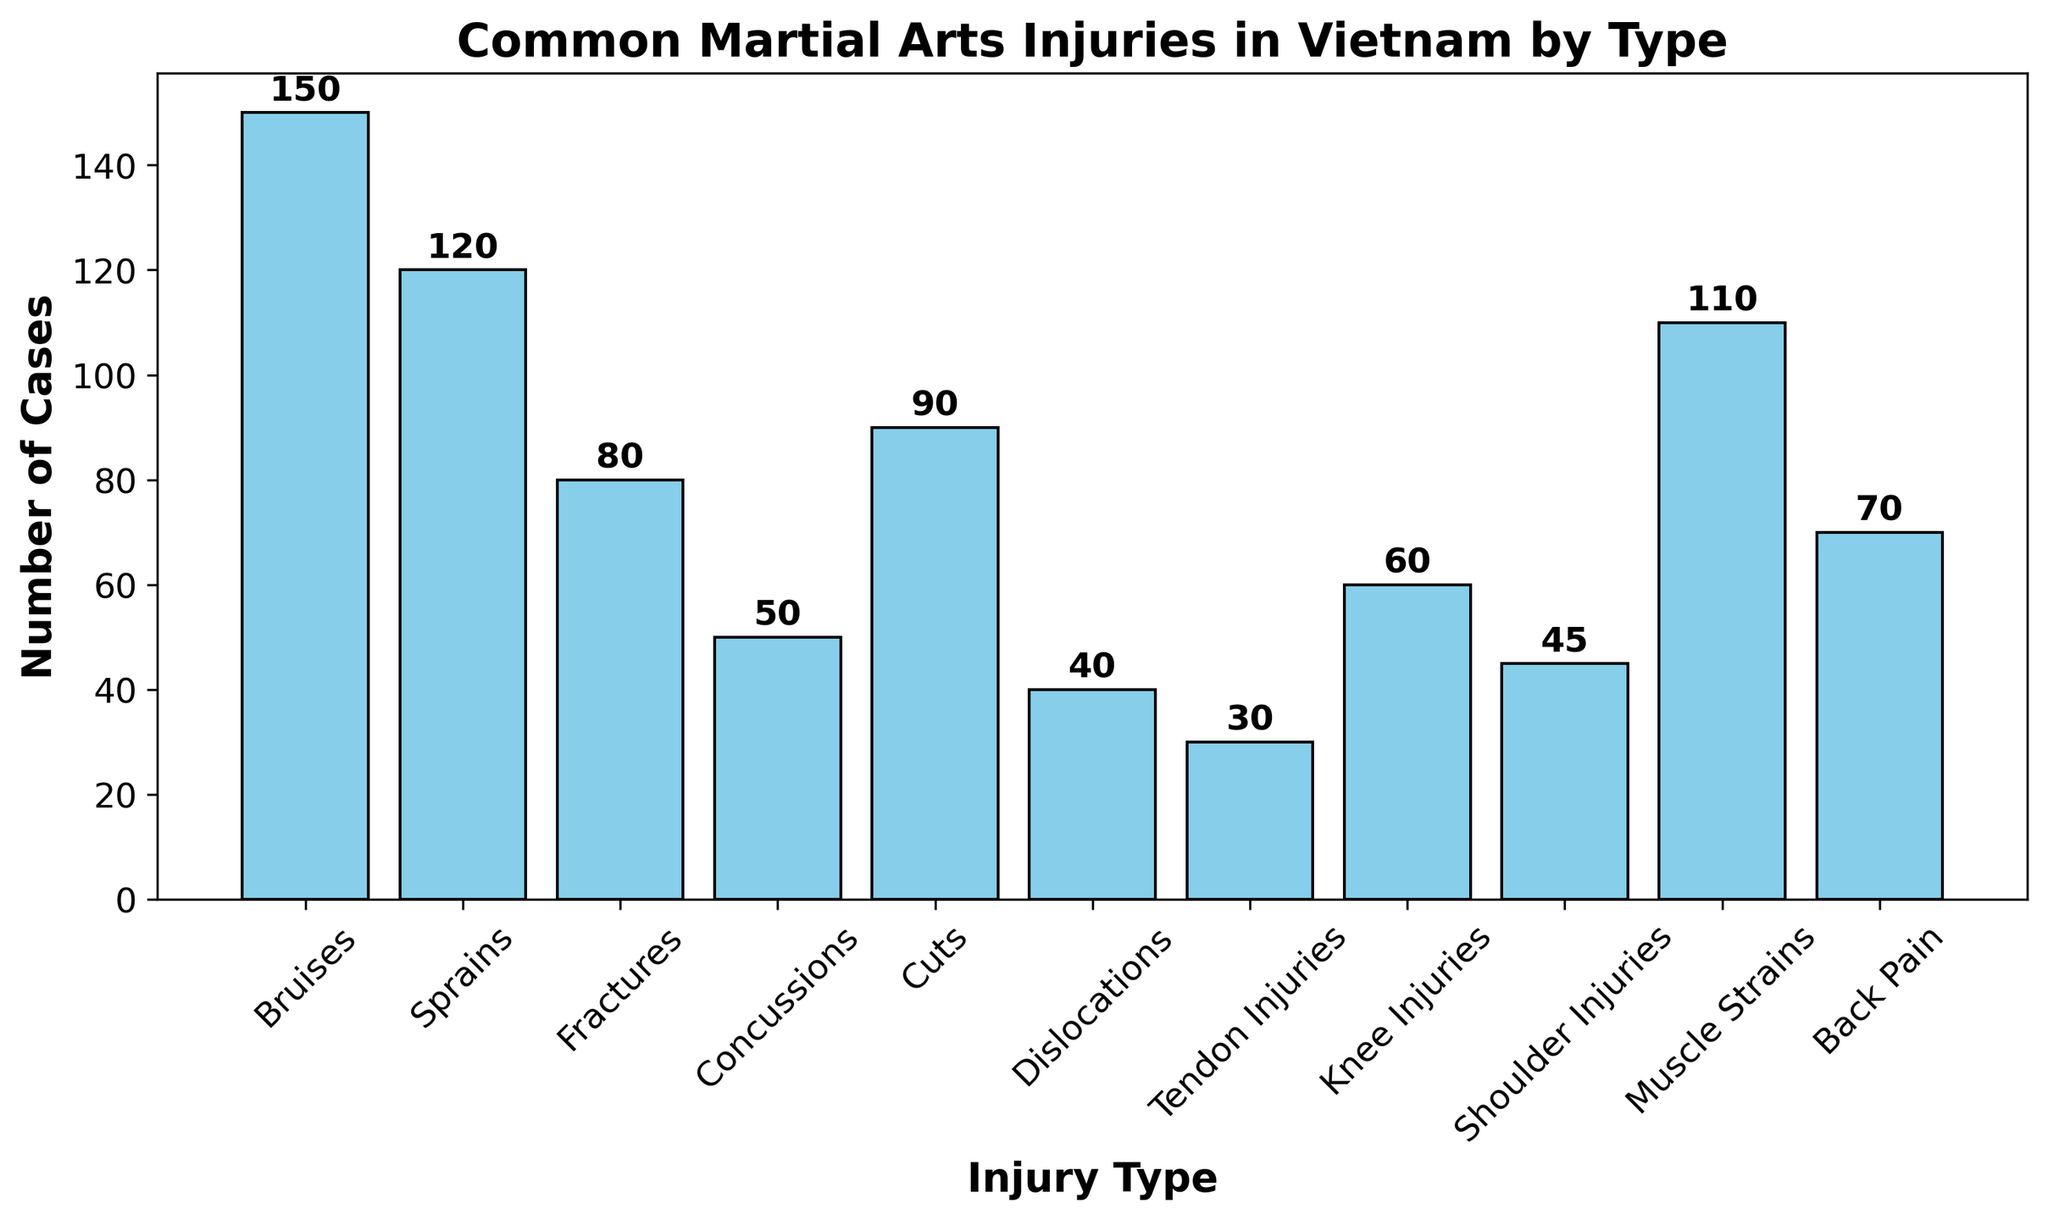What's the most common type of injury? To find the most common type of injury, look at the bar representing the highest number of cases. The tallest bar corresponds to "Bruises" with 150 cases.
Answer: Bruises Which injury type has the least number of cases? The shortest bar represents the injury type with the fewest cases. "Tendon Injuries" is the shortest bar with 30 cases.
Answer: Tendon Injuries How many more cases of bruises are there compared to fractures? Find the number of bruise cases (150) and fracture cases (80), then subtract the two: 150 - 80 = 70.
Answer: 70 What's the total number of cases for sprains, fractures, and concussions combined? Sum the figures for sprains (120), fractures (80), and concussions (50): 120 + 80 + 50 = 250.
Answer: 250 Are there more cases of muscle strains or knee injuries? Compare the heights of the bars for "Muscle Strains" (110) and "Knee Injuries" (60). Muscle Strains has more cases.
Answer: Muscle Strains Which injuries have more than 100 cases? Identify the bars taller than the 100-case mark. "Bruises" (150), "Sprains" (120), and "Muscle Strains" (110) have more than 100 cases.
Answer: Bruises, Sprains, Muscle Strains What are the total cases for dislocations and shoulder injuries combined? Add the cases for dislocations (40) and shoulder injuries (45): 40 + 45 = 85.
Answer: 85 Does back pain have more cases than concussions? Compare the heights of the bars for "Back Pain" (70) and "Concussions" (50). "Back Pain" has more cases.
Answer: Yes Which injury type has exactly 50 cases? Find the bar that corresponds exactly to 50 cases. "Concussions" fits this criterion.
Answer: Concussions How many types of injuries have between 40 and 80 cases? Count the bars between 40 and 80 cases: "Fractures" (80), "Cuts" (90), "Knee Injuries" (60), "Shoulder Injuries" (45), "Back Pain" (70). There are four of them.
Answer: 4 